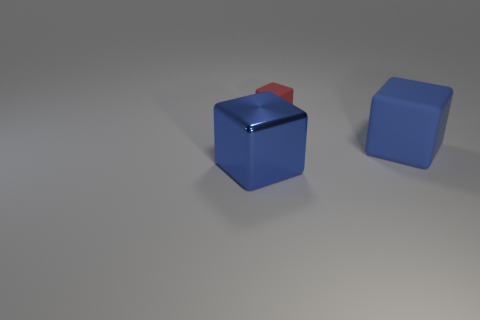Subtract all blue cubes. How many cubes are left? 1 Subtract all purple balls. How many blue cubes are left? 2 Add 2 shiny objects. How many objects exist? 5 Subtract all red blocks. How many blocks are left? 2 Subtract all cyan cubes. Subtract all brown cylinders. How many cubes are left? 3 Subtract all small red blocks. Subtract all small red things. How many objects are left? 1 Add 1 red cubes. How many red cubes are left? 2 Add 2 small red rubber cubes. How many small red rubber cubes exist? 3 Subtract 0 purple cylinders. How many objects are left? 3 